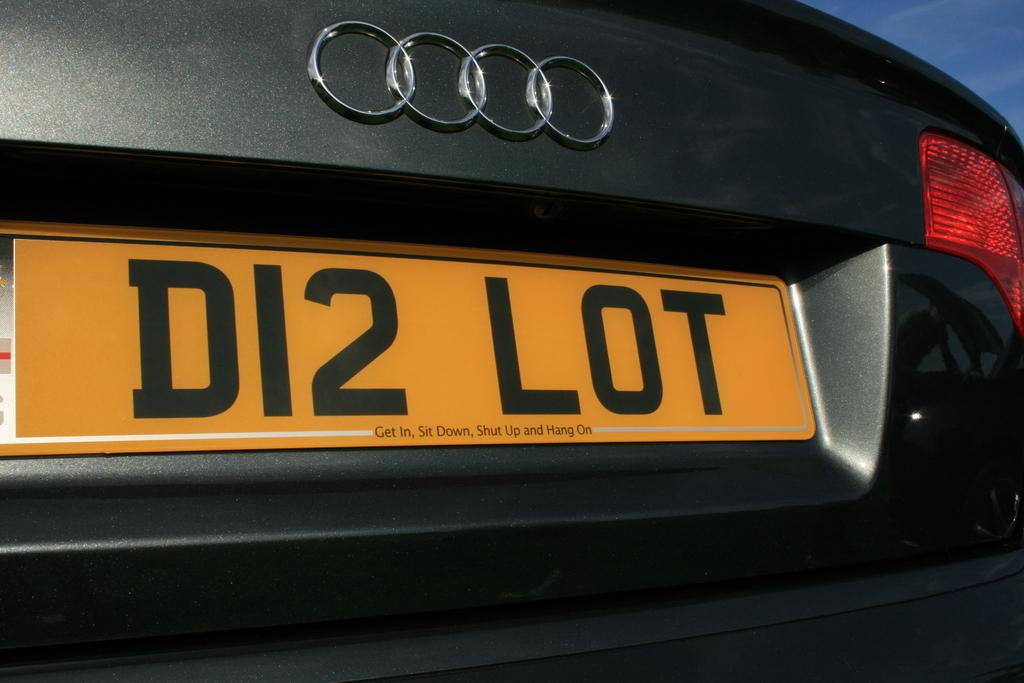<image>
Share a concise interpretation of the image provided. An Audi has a yellow license plate that reads D12 LOT 